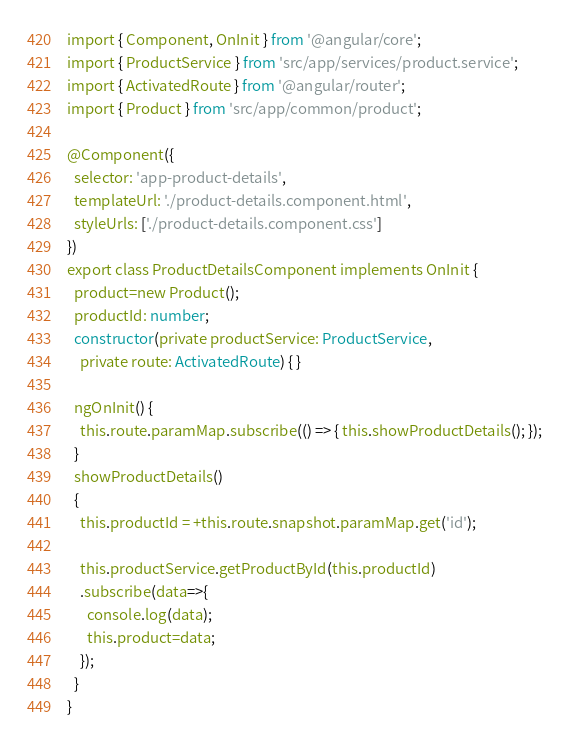<code> <loc_0><loc_0><loc_500><loc_500><_TypeScript_>import { Component, OnInit } from '@angular/core';
import { ProductService } from 'src/app/services/product.service';
import { ActivatedRoute } from '@angular/router';
import { Product } from 'src/app/common/product';

@Component({
  selector: 'app-product-details',
  templateUrl: './product-details.component.html',
  styleUrls: ['./product-details.component.css']
})
export class ProductDetailsComponent implements OnInit {
  product=new Product();
  productId: number;
  constructor(private productService: ProductService,
    private route: ActivatedRoute) { }

  ngOnInit() {
    this.route.paramMap.subscribe(() => { this.showProductDetails(); });
  }
  showProductDetails()
  {
    this.productId = +this.route.snapshot.paramMap.get('id');

    this.productService.getProductById(this.productId)
    .subscribe(data=>{
      console.log(data);
      this.product=data;
    });
  }
}
</code> 